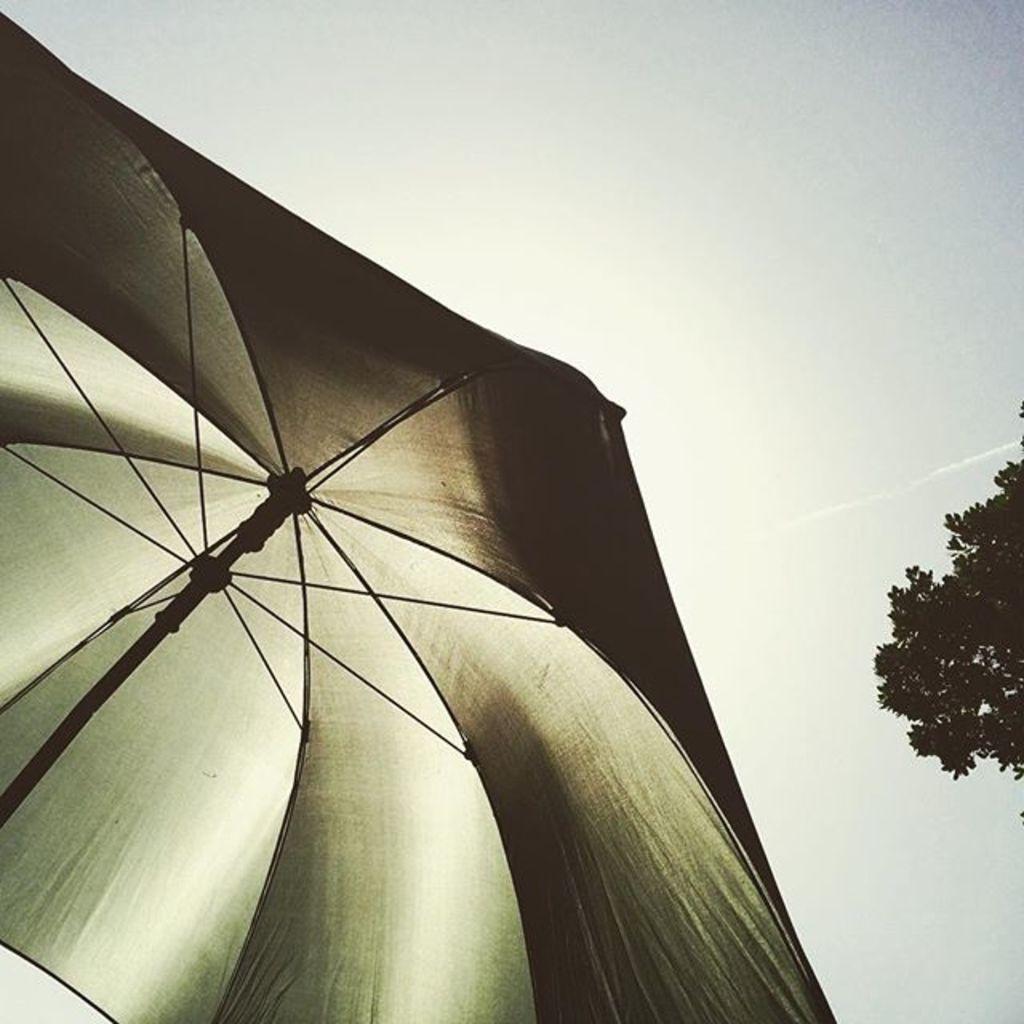How would you summarize this image in a sentence or two? We can see umbrella and tree. In the background we can see sky. 